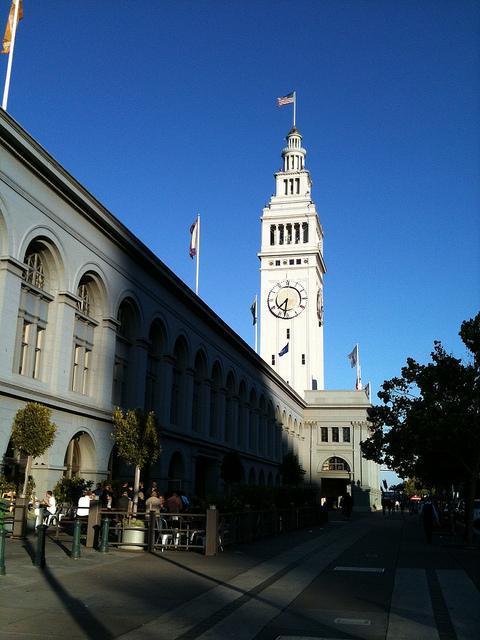How many of the motorcycles are blue?
Give a very brief answer. 0. 